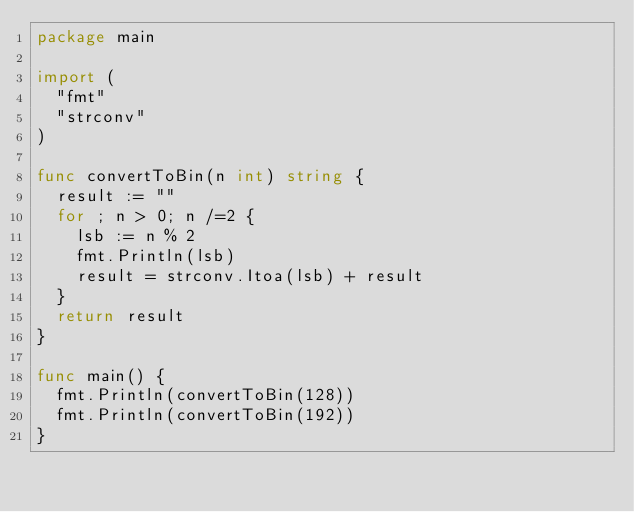<code> <loc_0><loc_0><loc_500><loc_500><_Go_>package main

import (
	"fmt"
	"strconv"
)

func convertToBin(n int) string {
	result := ""
	for ; n > 0; n /=2 {
		lsb := n % 2
		fmt.Println(lsb)
		result = strconv.Itoa(lsb) + result
	}
	return result
}

func main() {
	fmt.Println(convertToBin(128))
	fmt.Println(convertToBin(192))
}
</code> 